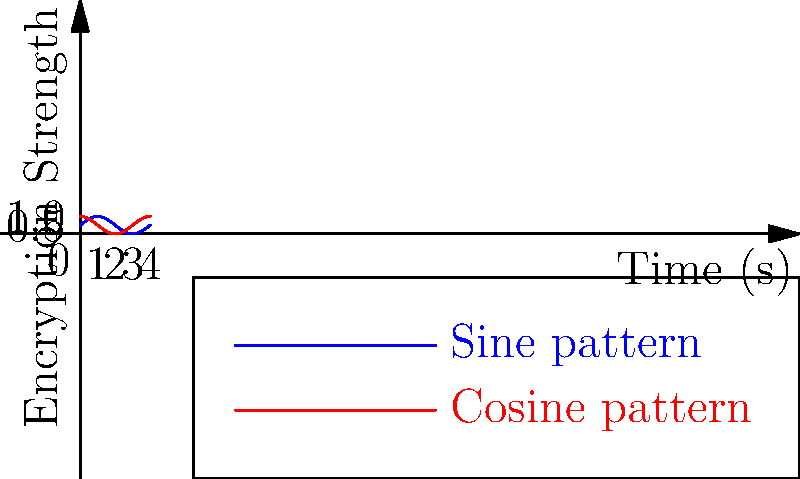In a Go-based encryption system, two periodic functions model the encryption strength over time:

$$f(t) = 0.5\sin(\frac{\pi t}{2}) + 0.5$$
$$g(t) = 0.5\cos(\frac{\pi t}{2}) + 0.5$$

Where $t$ is time in seconds and the output is the encryption strength (0 to 1). At what time $t$ in the interval $[0, 4]$ do the encryption strengths of both functions become equal? To find when the encryption strengths are equal, we need to solve the equation:

$$f(t) = g(t)$$

Substituting the given functions:

$$0.5\sin(\frac{\pi t}{2}) + 0.5 = 0.5\cos(\frac{\pi t}{2}) + 0.5$$

Simplifying:

$$\sin(\frac{\pi t}{2}) = \cos(\frac{\pi t}{2})$$

This equality holds true when:

$$\frac{\pi t}{2} = \frac{\pi}{4} + n\pi$$, where $n$ is an integer.

Solving for $t$:

$$t = \frac{1}{2} + 2n$$

In the interval $[0, 4]$, this equation is satisfied when $n = 0$ and $n = 1$, giving us:

$$t = 0.5$$ and $$t = 2.5$$

These points correspond to the intersections of the sine and cosine curves in the graph.
Answer: $t = 0.5$ and $t = 2.5$ seconds 